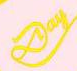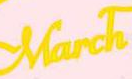What text appears in these images from left to right, separated by a semicolon? Day; March 